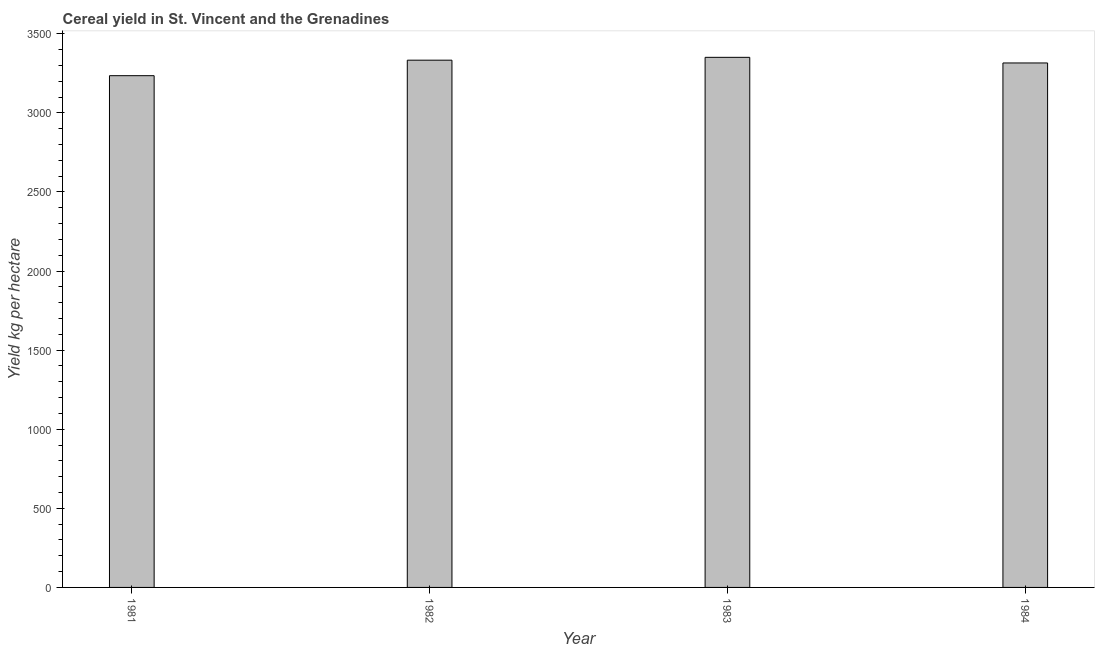Does the graph contain grids?
Your response must be concise. No. What is the title of the graph?
Offer a terse response. Cereal yield in St. Vincent and the Grenadines. What is the label or title of the X-axis?
Offer a very short reply. Year. What is the label or title of the Y-axis?
Keep it short and to the point. Yield kg per hectare. What is the cereal yield in 1981?
Keep it short and to the point. 3235.29. Across all years, what is the maximum cereal yield?
Offer a terse response. 3351.35. Across all years, what is the minimum cereal yield?
Make the answer very short. 3235.29. In which year was the cereal yield maximum?
Your answer should be compact. 1983. In which year was the cereal yield minimum?
Your answer should be compact. 1981. What is the sum of the cereal yield?
Provide a succinct answer. 1.32e+04. What is the difference between the cereal yield in 1981 and 1984?
Provide a short and direct response. -80.5. What is the average cereal yield per year?
Ensure brevity in your answer.  3308.94. What is the median cereal yield?
Your answer should be very brief. 3324.56. Is the cereal yield in 1981 less than that in 1983?
Keep it short and to the point. Yes. Is the difference between the cereal yield in 1982 and 1983 greater than the difference between any two years?
Provide a short and direct response. No. What is the difference between the highest and the second highest cereal yield?
Your response must be concise. 18.02. Is the sum of the cereal yield in 1981 and 1982 greater than the maximum cereal yield across all years?
Your answer should be very brief. Yes. What is the difference between the highest and the lowest cereal yield?
Give a very brief answer. 116.06. What is the difference between two consecutive major ticks on the Y-axis?
Your answer should be very brief. 500. What is the Yield kg per hectare in 1981?
Offer a very short reply. 3235.29. What is the Yield kg per hectare in 1982?
Your answer should be very brief. 3333.33. What is the Yield kg per hectare in 1983?
Offer a terse response. 3351.35. What is the Yield kg per hectare of 1984?
Offer a very short reply. 3315.79. What is the difference between the Yield kg per hectare in 1981 and 1982?
Ensure brevity in your answer.  -98.04. What is the difference between the Yield kg per hectare in 1981 and 1983?
Give a very brief answer. -116.06. What is the difference between the Yield kg per hectare in 1981 and 1984?
Give a very brief answer. -80.5. What is the difference between the Yield kg per hectare in 1982 and 1983?
Your answer should be compact. -18.02. What is the difference between the Yield kg per hectare in 1982 and 1984?
Give a very brief answer. 17.54. What is the difference between the Yield kg per hectare in 1983 and 1984?
Keep it short and to the point. 35.56. What is the ratio of the Yield kg per hectare in 1981 to that in 1982?
Provide a succinct answer. 0.97. What is the ratio of the Yield kg per hectare in 1981 to that in 1983?
Provide a succinct answer. 0.96. What is the ratio of the Yield kg per hectare in 1982 to that in 1983?
Give a very brief answer. 0.99. What is the ratio of the Yield kg per hectare in 1982 to that in 1984?
Your response must be concise. 1. 